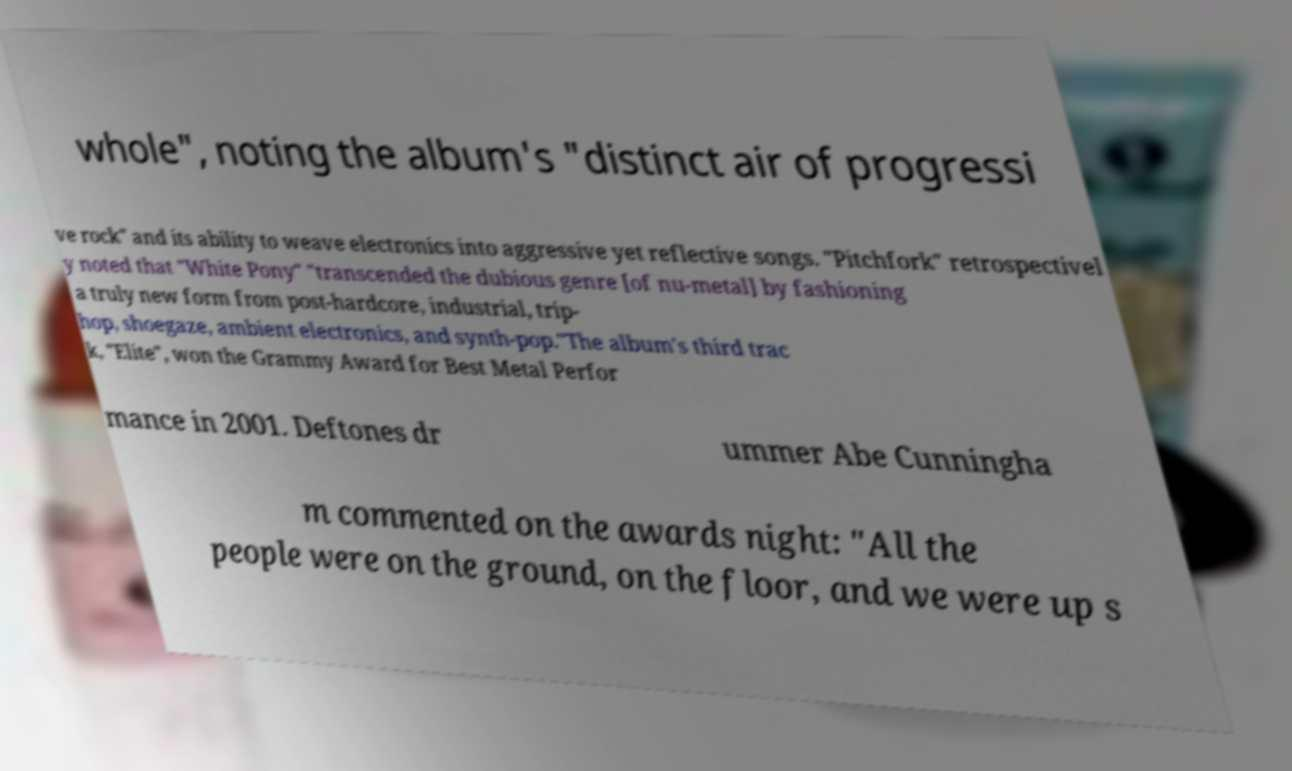What messages or text are displayed in this image? I need them in a readable, typed format. whole", noting the album's "distinct air of progressi ve rock" and its ability to weave electronics into aggressive yet reflective songs. "Pitchfork" retrospectivel y noted that "White Pony" "transcended the dubious genre [of nu-metal] by fashioning a truly new form from post-hardcore, industrial, trip- hop, shoegaze, ambient electronics, and synth-pop."The album's third trac k, "Elite", won the Grammy Award for Best Metal Perfor mance in 2001. Deftones dr ummer Abe Cunningha m commented on the awards night: "All the people were on the ground, on the floor, and we were up s 